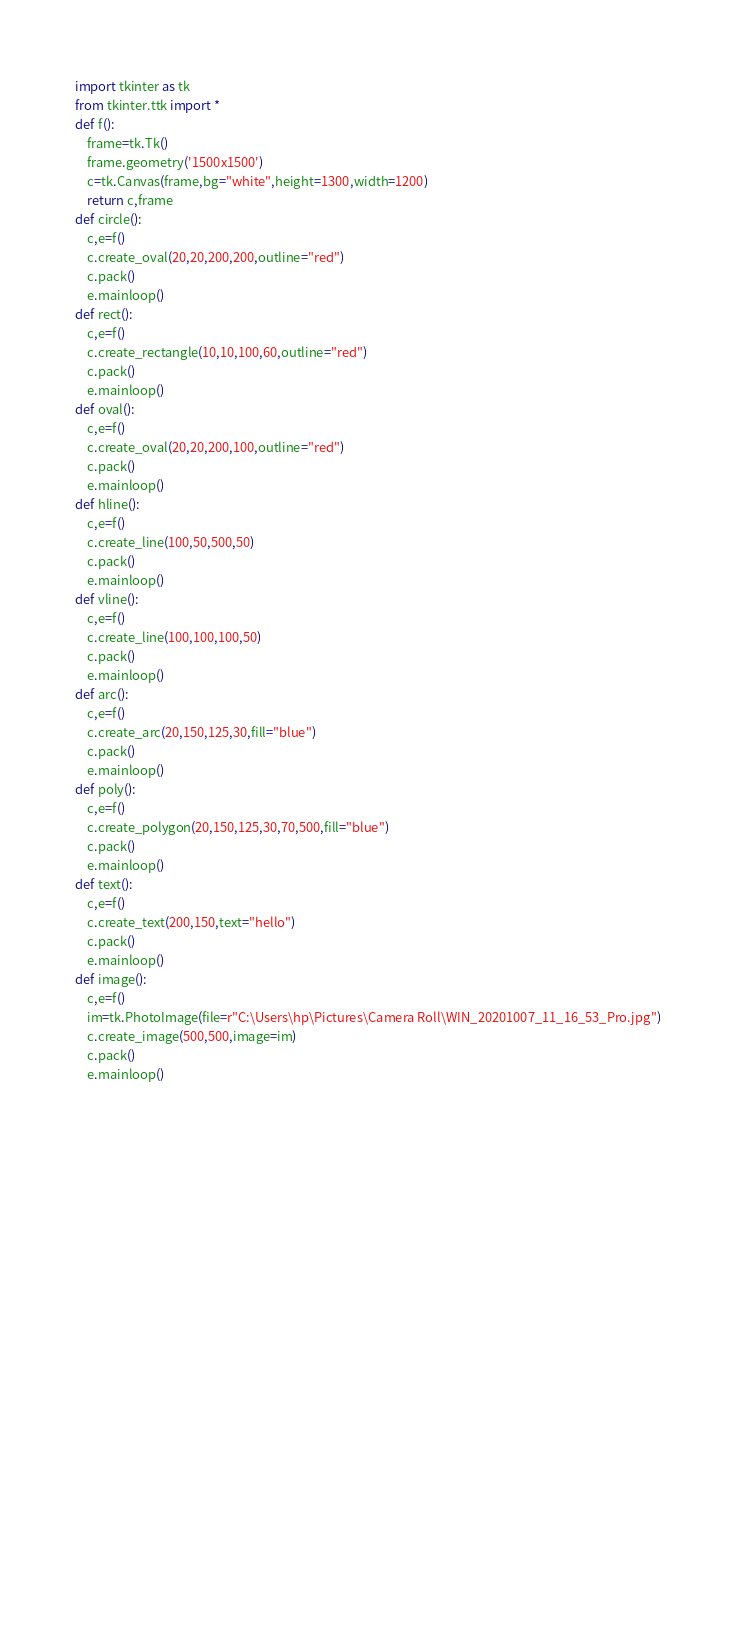Convert code to text. <code><loc_0><loc_0><loc_500><loc_500><_Python_>import tkinter as tk
from tkinter.ttk import *
def f():
    frame=tk.Tk()
    frame.geometry('1500x1500')
    c=tk.Canvas(frame,bg="white",height=1300,width=1200)
    return c,frame
def circle():
    c,e=f()
    c.create_oval(20,20,200,200,outline="red")
    c.pack()
    e.mainloop()
def rect():
    c,e=f()
    c.create_rectangle(10,10,100,60,outline="red")
    c.pack()
    e.mainloop()
def oval():
    c,e=f()
    c.create_oval(20,20,200,100,outline="red")
    c.pack()
    e.mainloop()
def hline():
    c,e=f()
    c.create_line(100,50,500,50)
    c.pack()
    e.mainloop()
def vline():
    c,e=f()
    c.create_line(100,100,100,50)
    c.pack()
    e.mainloop()
def arc():
    c,e=f()
    c.create_arc(20,150,125,30,fill="blue")
    c.pack()
    e.mainloop()
def poly():
    c,e=f()
    c.create_polygon(20,150,125,30,70,500,fill="blue")
    c.pack()
    e.mainloop()
def text():
    c,e=f()
    c.create_text(200,150,text="hello")
    c.pack()
    e.mainloop()
def image():
    c,e=f()
    im=tk.PhotoImage(file=r"C:\Users\hp\Pictures\Camera Roll\WIN_20201007_11_16_53_Pro.jpg")
    c.create_image(500,500,image=im)
    c.pack()
    e.mainloop()














    
    








    
    
</code> 